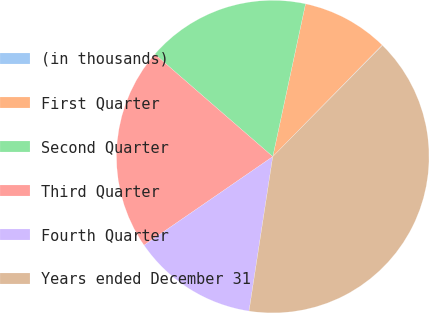Convert chart to OTSL. <chart><loc_0><loc_0><loc_500><loc_500><pie_chart><fcel>(in thousands)<fcel>First Quarter<fcel>Second Quarter<fcel>Third Quarter<fcel>Fourth Quarter<fcel>Years ended December 31<nl><fcel>0.05%<fcel>8.98%<fcel>16.98%<fcel>20.98%<fcel>12.98%<fcel>40.04%<nl></chart> 